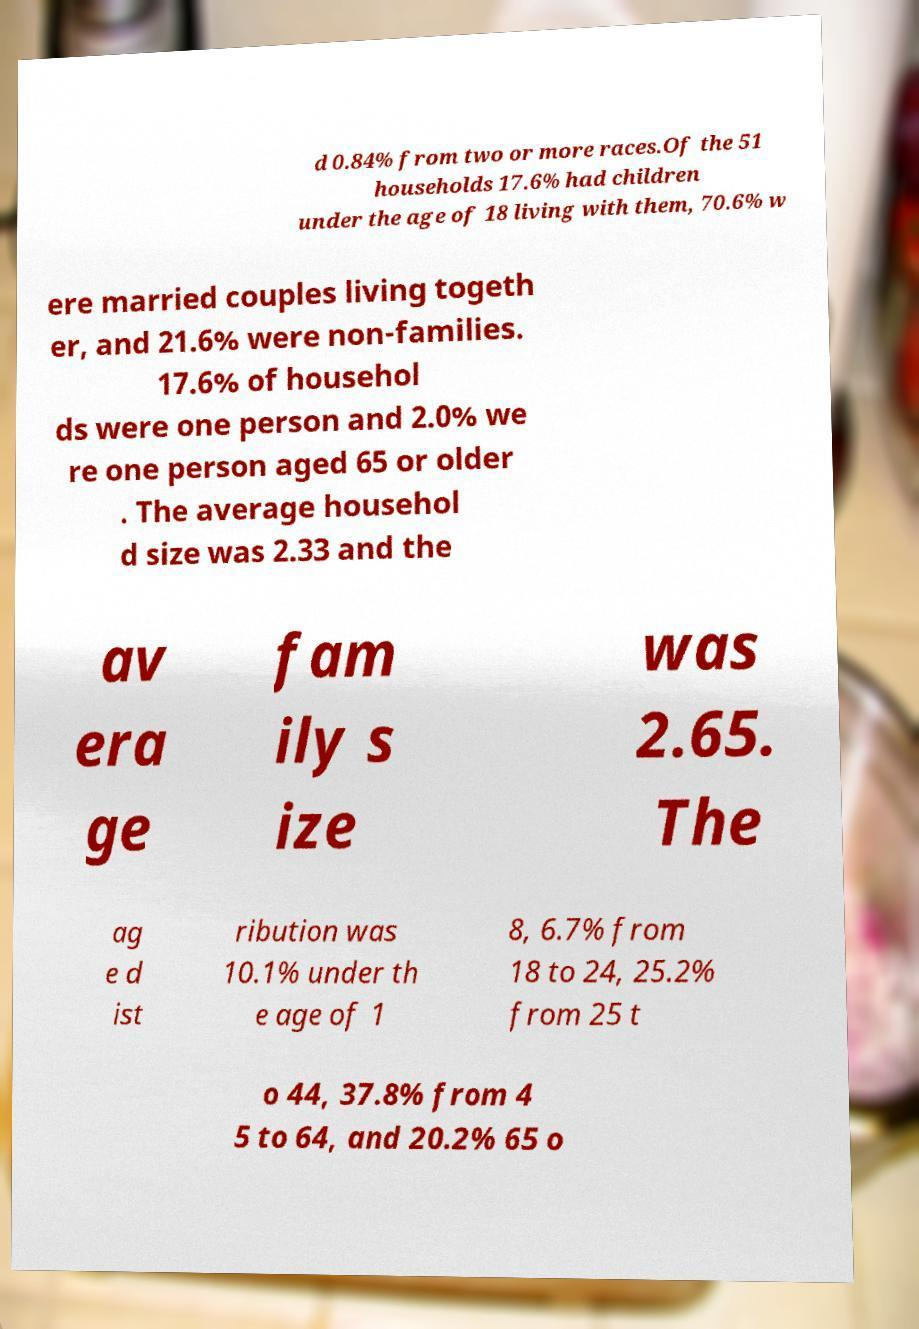Could you extract and type out the text from this image? d 0.84% from two or more races.Of the 51 households 17.6% had children under the age of 18 living with them, 70.6% w ere married couples living togeth er, and 21.6% were non-families. 17.6% of househol ds were one person and 2.0% we re one person aged 65 or older . The average househol d size was 2.33 and the av era ge fam ily s ize was 2.65. The ag e d ist ribution was 10.1% under th e age of 1 8, 6.7% from 18 to 24, 25.2% from 25 t o 44, 37.8% from 4 5 to 64, and 20.2% 65 o 